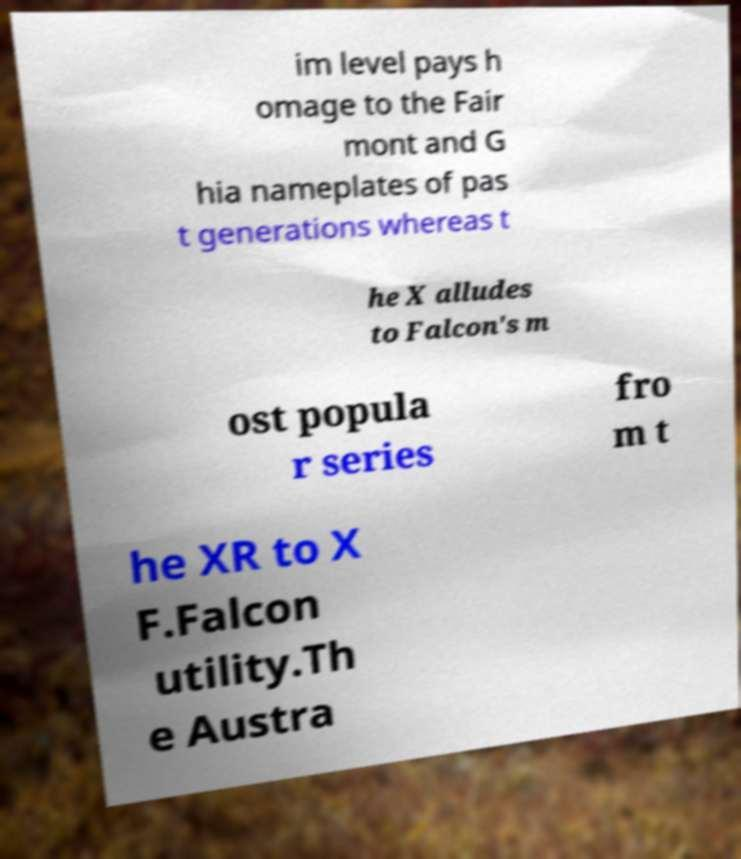I need the written content from this picture converted into text. Can you do that? im level pays h omage to the Fair mont and G hia nameplates of pas t generations whereas t he X alludes to Falcon's m ost popula r series fro m t he XR to X F.Falcon utility.Th e Austra 